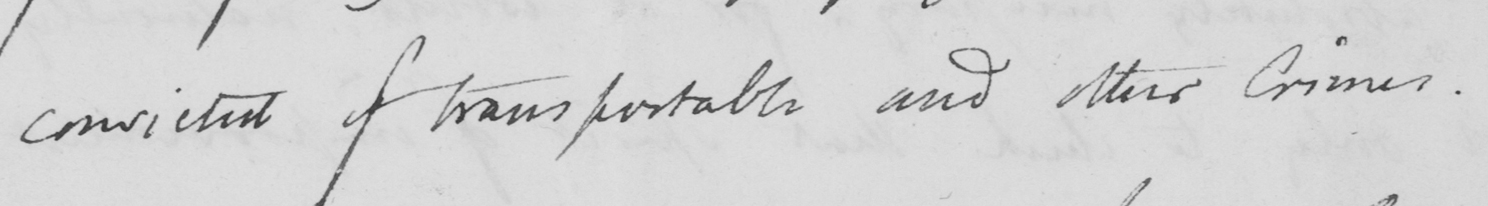What is written in this line of handwriting? convicted of transportable and other Crimes. 